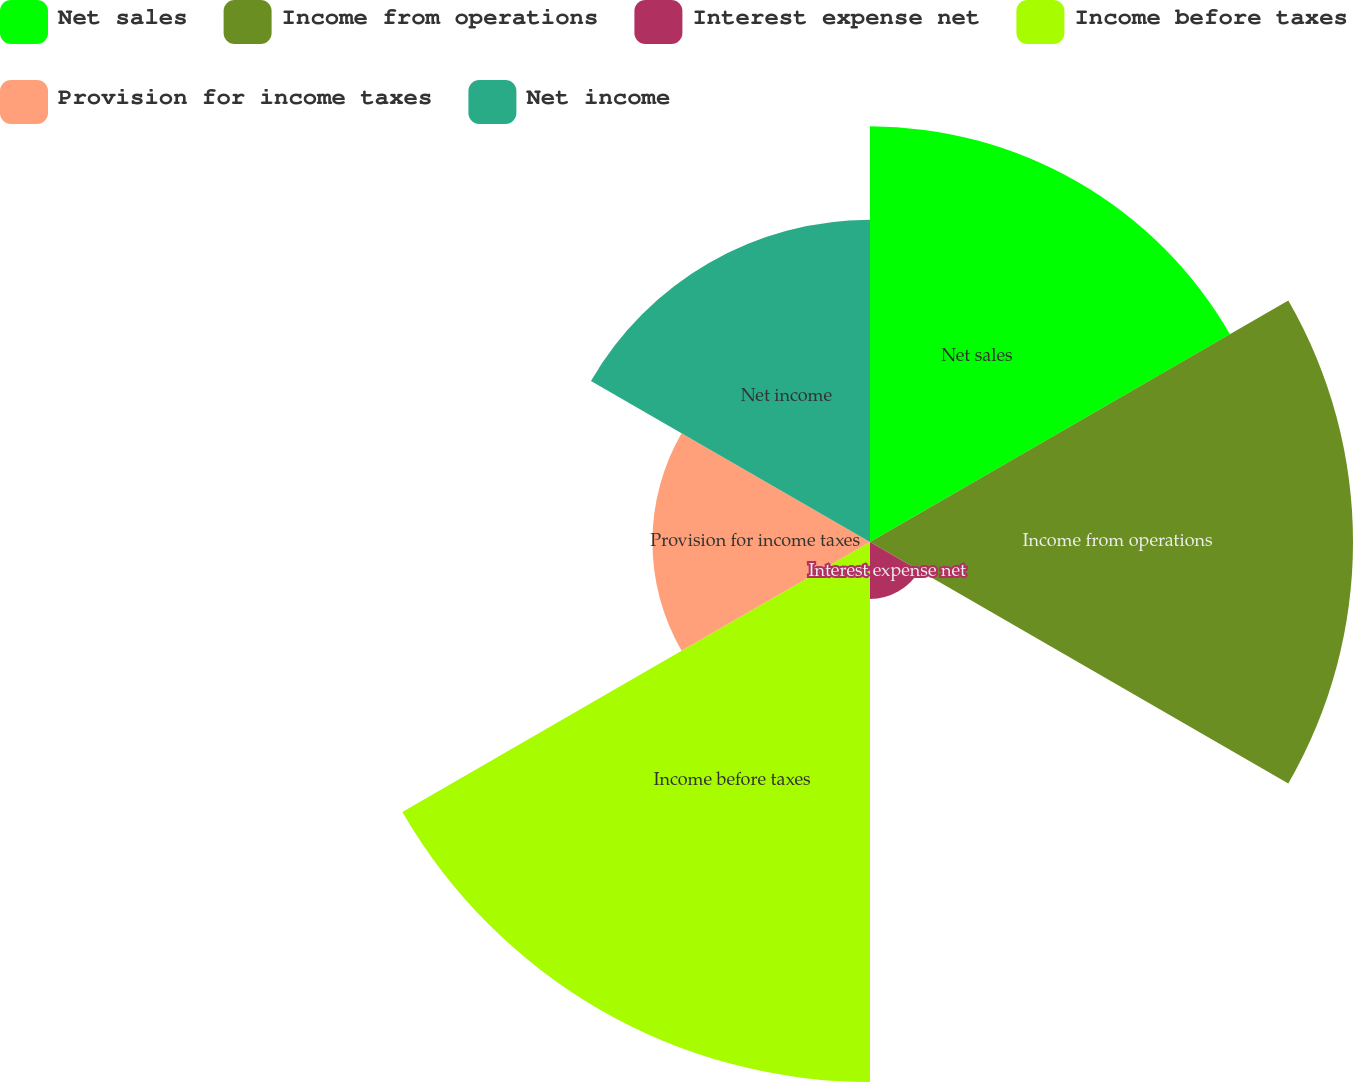<chart> <loc_0><loc_0><loc_500><loc_500><pie_chart><fcel>Net sales<fcel>Income from operations<fcel>Interest expense net<fcel>Income before taxes<fcel>Provision for income taxes<fcel>Net income<nl><fcel>20.42%<fcel>23.73%<fcel>2.8%<fcel>26.53%<fcel>10.69%<fcel>15.83%<nl></chart> 